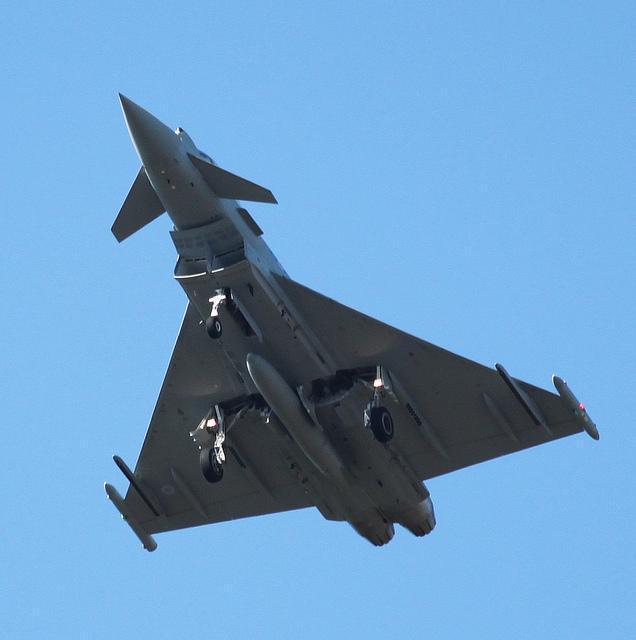How many airplanes are there?
Give a very brief answer. 1. 